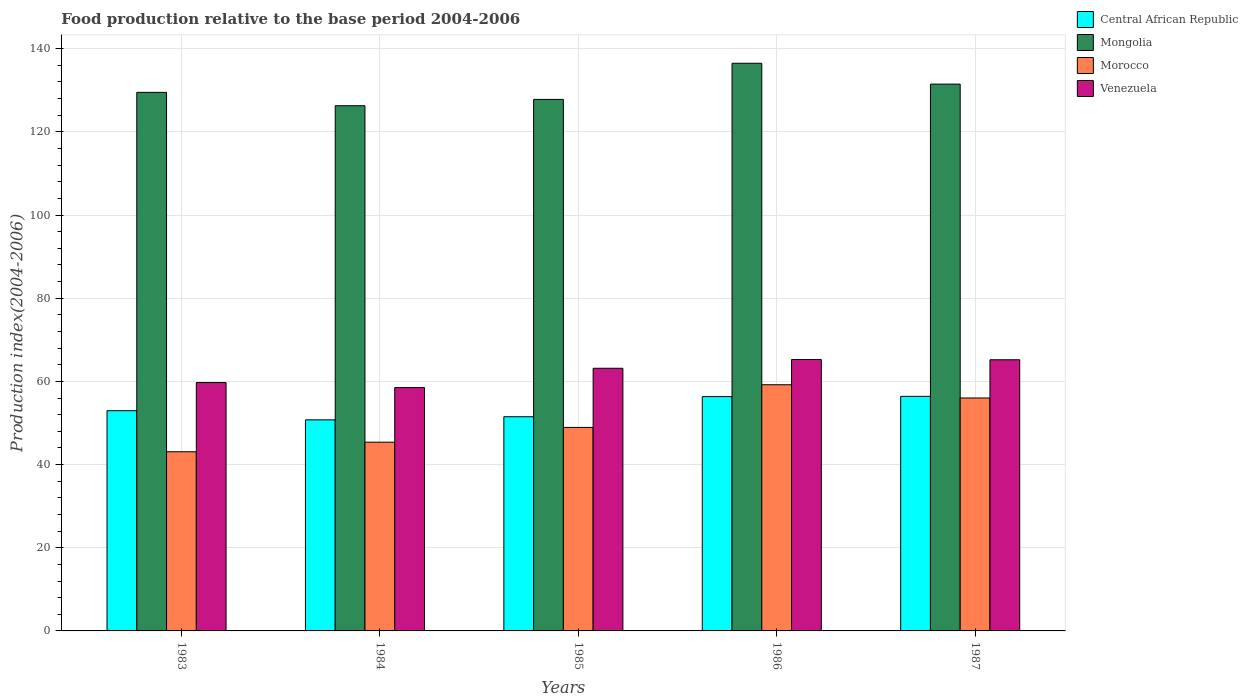How many different coloured bars are there?
Ensure brevity in your answer.  4. How many groups of bars are there?
Keep it short and to the point. 5. Are the number of bars per tick equal to the number of legend labels?
Give a very brief answer. Yes. How many bars are there on the 1st tick from the right?
Keep it short and to the point. 4. What is the label of the 5th group of bars from the left?
Provide a short and direct response. 1987. In how many cases, is the number of bars for a given year not equal to the number of legend labels?
Offer a terse response. 0. What is the food production index in Morocco in 1985?
Make the answer very short. 48.93. Across all years, what is the maximum food production index in Central African Republic?
Your answer should be very brief. 56.4. Across all years, what is the minimum food production index in Central African Republic?
Offer a very short reply. 50.75. In which year was the food production index in Venezuela maximum?
Provide a succinct answer. 1986. What is the total food production index in Venezuela in the graph?
Your response must be concise. 311.84. What is the difference between the food production index in Central African Republic in 1983 and that in 1986?
Ensure brevity in your answer.  -3.39. What is the difference between the food production index in Venezuela in 1987 and the food production index in Morocco in 1984?
Provide a short and direct response. 19.82. What is the average food production index in Central African Republic per year?
Provide a short and direct response. 53.59. In the year 1986, what is the difference between the food production index in Central African Republic and food production index in Morocco?
Ensure brevity in your answer.  -2.85. In how many years, is the food production index in Venezuela greater than 72?
Your response must be concise. 0. What is the ratio of the food production index in Venezuela in 1985 to that in 1987?
Your answer should be very brief. 0.97. What is the difference between the highest and the second highest food production index in Mongolia?
Ensure brevity in your answer.  5.01. What is the difference between the highest and the lowest food production index in Mongolia?
Your response must be concise. 10.21. Is it the case that in every year, the sum of the food production index in Venezuela and food production index in Morocco is greater than the sum of food production index in Mongolia and food production index in Central African Republic?
Provide a succinct answer. Yes. What does the 2nd bar from the left in 1987 represents?
Provide a short and direct response. Mongolia. What does the 2nd bar from the right in 1985 represents?
Ensure brevity in your answer.  Morocco. Is it the case that in every year, the sum of the food production index in Venezuela and food production index in Central African Republic is greater than the food production index in Morocco?
Provide a short and direct response. Yes. How many bars are there?
Make the answer very short. 20. How many years are there in the graph?
Provide a short and direct response. 5. What is the difference between two consecutive major ticks on the Y-axis?
Ensure brevity in your answer.  20. Does the graph contain any zero values?
Your answer should be compact. No. Does the graph contain grids?
Offer a terse response. Yes. How many legend labels are there?
Your answer should be very brief. 4. How are the legend labels stacked?
Offer a very short reply. Vertical. What is the title of the graph?
Your response must be concise. Food production relative to the base period 2004-2006. Does "Caribbean small states" appear as one of the legend labels in the graph?
Make the answer very short. No. What is the label or title of the X-axis?
Your response must be concise. Years. What is the label or title of the Y-axis?
Keep it short and to the point. Production index(2004-2006). What is the Production index(2004-2006) in Central African Republic in 1983?
Make the answer very short. 52.95. What is the Production index(2004-2006) in Mongolia in 1983?
Your answer should be compact. 129.49. What is the Production index(2004-2006) in Morocco in 1983?
Ensure brevity in your answer.  43.08. What is the Production index(2004-2006) in Venezuela in 1983?
Offer a terse response. 59.72. What is the Production index(2004-2006) of Central African Republic in 1984?
Provide a succinct answer. 50.75. What is the Production index(2004-2006) of Mongolia in 1984?
Offer a terse response. 126.28. What is the Production index(2004-2006) in Morocco in 1984?
Your answer should be very brief. 45.38. What is the Production index(2004-2006) of Venezuela in 1984?
Your response must be concise. 58.51. What is the Production index(2004-2006) of Central African Republic in 1985?
Ensure brevity in your answer.  51.5. What is the Production index(2004-2006) of Mongolia in 1985?
Offer a very short reply. 127.8. What is the Production index(2004-2006) in Morocco in 1985?
Provide a short and direct response. 48.93. What is the Production index(2004-2006) of Venezuela in 1985?
Your response must be concise. 63.15. What is the Production index(2004-2006) in Central African Republic in 1986?
Keep it short and to the point. 56.34. What is the Production index(2004-2006) of Mongolia in 1986?
Your answer should be very brief. 136.49. What is the Production index(2004-2006) in Morocco in 1986?
Give a very brief answer. 59.19. What is the Production index(2004-2006) of Venezuela in 1986?
Provide a short and direct response. 65.26. What is the Production index(2004-2006) of Central African Republic in 1987?
Offer a terse response. 56.4. What is the Production index(2004-2006) of Mongolia in 1987?
Offer a terse response. 131.48. What is the Production index(2004-2006) of Morocco in 1987?
Ensure brevity in your answer.  56.01. What is the Production index(2004-2006) of Venezuela in 1987?
Keep it short and to the point. 65.2. Across all years, what is the maximum Production index(2004-2006) in Central African Republic?
Your answer should be compact. 56.4. Across all years, what is the maximum Production index(2004-2006) in Mongolia?
Provide a short and direct response. 136.49. Across all years, what is the maximum Production index(2004-2006) in Morocco?
Your answer should be compact. 59.19. Across all years, what is the maximum Production index(2004-2006) of Venezuela?
Your answer should be compact. 65.26. Across all years, what is the minimum Production index(2004-2006) of Central African Republic?
Make the answer very short. 50.75. Across all years, what is the minimum Production index(2004-2006) in Mongolia?
Offer a terse response. 126.28. Across all years, what is the minimum Production index(2004-2006) of Morocco?
Your response must be concise. 43.08. Across all years, what is the minimum Production index(2004-2006) of Venezuela?
Offer a very short reply. 58.51. What is the total Production index(2004-2006) in Central African Republic in the graph?
Your answer should be very brief. 267.94. What is the total Production index(2004-2006) of Mongolia in the graph?
Your answer should be compact. 651.54. What is the total Production index(2004-2006) in Morocco in the graph?
Your answer should be compact. 252.59. What is the total Production index(2004-2006) of Venezuela in the graph?
Keep it short and to the point. 311.84. What is the difference between the Production index(2004-2006) of Mongolia in 1983 and that in 1984?
Offer a very short reply. 3.21. What is the difference between the Production index(2004-2006) in Venezuela in 1983 and that in 1984?
Your response must be concise. 1.21. What is the difference between the Production index(2004-2006) of Central African Republic in 1983 and that in 1985?
Give a very brief answer. 1.45. What is the difference between the Production index(2004-2006) in Mongolia in 1983 and that in 1985?
Keep it short and to the point. 1.69. What is the difference between the Production index(2004-2006) of Morocco in 1983 and that in 1985?
Your answer should be very brief. -5.85. What is the difference between the Production index(2004-2006) of Venezuela in 1983 and that in 1985?
Offer a very short reply. -3.43. What is the difference between the Production index(2004-2006) of Central African Republic in 1983 and that in 1986?
Provide a short and direct response. -3.39. What is the difference between the Production index(2004-2006) in Morocco in 1983 and that in 1986?
Ensure brevity in your answer.  -16.11. What is the difference between the Production index(2004-2006) of Venezuela in 1983 and that in 1986?
Your response must be concise. -5.54. What is the difference between the Production index(2004-2006) of Central African Republic in 1983 and that in 1987?
Your answer should be compact. -3.45. What is the difference between the Production index(2004-2006) of Mongolia in 1983 and that in 1987?
Make the answer very short. -1.99. What is the difference between the Production index(2004-2006) of Morocco in 1983 and that in 1987?
Keep it short and to the point. -12.93. What is the difference between the Production index(2004-2006) of Venezuela in 1983 and that in 1987?
Your answer should be very brief. -5.48. What is the difference between the Production index(2004-2006) in Central African Republic in 1984 and that in 1985?
Offer a very short reply. -0.75. What is the difference between the Production index(2004-2006) of Mongolia in 1984 and that in 1985?
Keep it short and to the point. -1.52. What is the difference between the Production index(2004-2006) of Morocco in 1984 and that in 1985?
Provide a short and direct response. -3.55. What is the difference between the Production index(2004-2006) in Venezuela in 1984 and that in 1985?
Offer a terse response. -4.64. What is the difference between the Production index(2004-2006) of Central African Republic in 1984 and that in 1986?
Keep it short and to the point. -5.59. What is the difference between the Production index(2004-2006) of Mongolia in 1984 and that in 1986?
Give a very brief answer. -10.21. What is the difference between the Production index(2004-2006) of Morocco in 1984 and that in 1986?
Ensure brevity in your answer.  -13.81. What is the difference between the Production index(2004-2006) in Venezuela in 1984 and that in 1986?
Your answer should be very brief. -6.75. What is the difference between the Production index(2004-2006) of Central African Republic in 1984 and that in 1987?
Your response must be concise. -5.65. What is the difference between the Production index(2004-2006) of Mongolia in 1984 and that in 1987?
Your answer should be very brief. -5.2. What is the difference between the Production index(2004-2006) of Morocco in 1984 and that in 1987?
Your answer should be compact. -10.63. What is the difference between the Production index(2004-2006) in Venezuela in 1984 and that in 1987?
Ensure brevity in your answer.  -6.69. What is the difference between the Production index(2004-2006) of Central African Republic in 1985 and that in 1986?
Give a very brief answer. -4.84. What is the difference between the Production index(2004-2006) in Mongolia in 1985 and that in 1986?
Offer a very short reply. -8.69. What is the difference between the Production index(2004-2006) of Morocco in 1985 and that in 1986?
Provide a succinct answer. -10.26. What is the difference between the Production index(2004-2006) in Venezuela in 1985 and that in 1986?
Your response must be concise. -2.11. What is the difference between the Production index(2004-2006) of Central African Republic in 1985 and that in 1987?
Offer a terse response. -4.9. What is the difference between the Production index(2004-2006) of Mongolia in 1985 and that in 1987?
Offer a terse response. -3.68. What is the difference between the Production index(2004-2006) of Morocco in 1985 and that in 1987?
Keep it short and to the point. -7.08. What is the difference between the Production index(2004-2006) in Venezuela in 1985 and that in 1987?
Give a very brief answer. -2.05. What is the difference between the Production index(2004-2006) in Central African Republic in 1986 and that in 1987?
Your answer should be very brief. -0.06. What is the difference between the Production index(2004-2006) of Mongolia in 1986 and that in 1987?
Keep it short and to the point. 5.01. What is the difference between the Production index(2004-2006) in Morocco in 1986 and that in 1987?
Give a very brief answer. 3.18. What is the difference between the Production index(2004-2006) of Central African Republic in 1983 and the Production index(2004-2006) of Mongolia in 1984?
Keep it short and to the point. -73.33. What is the difference between the Production index(2004-2006) in Central African Republic in 1983 and the Production index(2004-2006) in Morocco in 1984?
Your response must be concise. 7.57. What is the difference between the Production index(2004-2006) of Central African Republic in 1983 and the Production index(2004-2006) of Venezuela in 1984?
Make the answer very short. -5.56. What is the difference between the Production index(2004-2006) of Mongolia in 1983 and the Production index(2004-2006) of Morocco in 1984?
Provide a succinct answer. 84.11. What is the difference between the Production index(2004-2006) in Mongolia in 1983 and the Production index(2004-2006) in Venezuela in 1984?
Your response must be concise. 70.98. What is the difference between the Production index(2004-2006) in Morocco in 1983 and the Production index(2004-2006) in Venezuela in 1984?
Your answer should be compact. -15.43. What is the difference between the Production index(2004-2006) in Central African Republic in 1983 and the Production index(2004-2006) in Mongolia in 1985?
Provide a short and direct response. -74.85. What is the difference between the Production index(2004-2006) of Central African Republic in 1983 and the Production index(2004-2006) of Morocco in 1985?
Ensure brevity in your answer.  4.02. What is the difference between the Production index(2004-2006) in Mongolia in 1983 and the Production index(2004-2006) in Morocco in 1985?
Your answer should be very brief. 80.56. What is the difference between the Production index(2004-2006) of Mongolia in 1983 and the Production index(2004-2006) of Venezuela in 1985?
Provide a short and direct response. 66.34. What is the difference between the Production index(2004-2006) in Morocco in 1983 and the Production index(2004-2006) in Venezuela in 1985?
Offer a terse response. -20.07. What is the difference between the Production index(2004-2006) in Central African Republic in 1983 and the Production index(2004-2006) in Mongolia in 1986?
Your response must be concise. -83.54. What is the difference between the Production index(2004-2006) in Central African Republic in 1983 and the Production index(2004-2006) in Morocco in 1986?
Ensure brevity in your answer.  -6.24. What is the difference between the Production index(2004-2006) of Central African Republic in 1983 and the Production index(2004-2006) of Venezuela in 1986?
Give a very brief answer. -12.31. What is the difference between the Production index(2004-2006) of Mongolia in 1983 and the Production index(2004-2006) of Morocco in 1986?
Your answer should be very brief. 70.3. What is the difference between the Production index(2004-2006) in Mongolia in 1983 and the Production index(2004-2006) in Venezuela in 1986?
Offer a very short reply. 64.23. What is the difference between the Production index(2004-2006) of Morocco in 1983 and the Production index(2004-2006) of Venezuela in 1986?
Give a very brief answer. -22.18. What is the difference between the Production index(2004-2006) of Central African Republic in 1983 and the Production index(2004-2006) of Mongolia in 1987?
Your answer should be very brief. -78.53. What is the difference between the Production index(2004-2006) of Central African Republic in 1983 and the Production index(2004-2006) of Morocco in 1987?
Keep it short and to the point. -3.06. What is the difference between the Production index(2004-2006) in Central African Republic in 1983 and the Production index(2004-2006) in Venezuela in 1987?
Your answer should be very brief. -12.25. What is the difference between the Production index(2004-2006) of Mongolia in 1983 and the Production index(2004-2006) of Morocco in 1987?
Keep it short and to the point. 73.48. What is the difference between the Production index(2004-2006) in Mongolia in 1983 and the Production index(2004-2006) in Venezuela in 1987?
Your answer should be very brief. 64.29. What is the difference between the Production index(2004-2006) in Morocco in 1983 and the Production index(2004-2006) in Venezuela in 1987?
Provide a short and direct response. -22.12. What is the difference between the Production index(2004-2006) of Central African Republic in 1984 and the Production index(2004-2006) of Mongolia in 1985?
Offer a very short reply. -77.05. What is the difference between the Production index(2004-2006) of Central African Republic in 1984 and the Production index(2004-2006) of Morocco in 1985?
Provide a succinct answer. 1.82. What is the difference between the Production index(2004-2006) of Mongolia in 1984 and the Production index(2004-2006) of Morocco in 1985?
Your answer should be compact. 77.35. What is the difference between the Production index(2004-2006) in Mongolia in 1984 and the Production index(2004-2006) in Venezuela in 1985?
Offer a terse response. 63.13. What is the difference between the Production index(2004-2006) of Morocco in 1984 and the Production index(2004-2006) of Venezuela in 1985?
Keep it short and to the point. -17.77. What is the difference between the Production index(2004-2006) in Central African Republic in 1984 and the Production index(2004-2006) in Mongolia in 1986?
Ensure brevity in your answer.  -85.74. What is the difference between the Production index(2004-2006) in Central African Republic in 1984 and the Production index(2004-2006) in Morocco in 1986?
Provide a short and direct response. -8.44. What is the difference between the Production index(2004-2006) of Central African Republic in 1984 and the Production index(2004-2006) of Venezuela in 1986?
Make the answer very short. -14.51. What is the difference between the Production index(2004-2006) of Mongolia in 1984 and the Production index(2004-2006) of Morocco in 1986?
Your answer should be very brief. 67.09. What is the difference between the Production index(2004-2006) of Mongolia in 1984 and the Production index(2004-2006) of Venezuela in 1986?
Keep it short and to the point. 61.02. What is the difference between the Production index(2004-2006) in Morocco in 1984 and the Production index(2004-2006) in Venezuela in 1986?
Give a very brief answer. -19.88. What is the difference between the Production index(2004-2006) in Central African Republic in 1984 and the Production index(2004-2006) in Mongolia in 1987?
Keep it short and to the point. -80.73. What is the difference between the Production index(2004-2006) of Central African Republic in 1984 and the Production index(2004-2006) of Morocco in 1987?
Ensure brevity in your answer.  -5.26. What is the difference between the Production index(2004-2006) of Central African Republic in 1984 and the Production index(2004-2006) of Venezuela in 1987?
Keep it short and to the point. -14.45. What is the difference between the Production index(2004-2006) in Mongolia in 1984 and the Production index(2004-2006) in Morocco in 1987?
Offer a terse response. 70.27. What is the difference between the Production index(2004-2006) of Mongolia in 1984 and the Production index(2004-2006) of Venezuela in 1987?
Ensure brevity in your answer.  61.08. What is the difference between the Production index(2004-2006) of Morocco in 1984 and the Production index(2004-2006) of Venezuela in 1987?
Ensure brevity in your answer.  -19.82. What is the difference between the Production index(2004-2006) of Central African Republic in 1985 and the Production index(2004-2006) of Mongolia in 1986?
Ensure brevity in your answer.  -84.99. What is the difference between the Production index(2004-2006) of Central African Republic in 1985 and the Production index(2004-2006) of Morocco in 1986?
Ensure brevity in your answer.  -7.69. What is the difference between the Production index(2004-2006) of Central African Republic in 1985 and the Production index(2004-2006) of Venezuela in 1986?
Offer a very short reply. -13.76. What is the difference between the Production index(2004-2006) of Mongolia in 1985 and the Production index(2004-2006) of Morocco in 1986?
Give a very brief answer. 68.61. What is the difference between the Production index(2004-2006) of Mongolia in 1985 and the Production index(2004-2006) of Venezuela in 1986?
Your response must be concise. 62.54. What is the difference between the Production index(2004-2006) in Morocco in 1985 and the Production index(2004-2006) in Venezuela in 1986?
Your answer should be very brief. -16.33. What is the difference between the Production index(2004-2006) in Central African Republic in 1985 and the Production index(2004-2006) in Mongolia in 1987?
Your response must be concise. -79.98. What is the difference between the Production index(2004-2006) of Central African Republic in 1985 and the Production index(2004-2006) of Morocco in 1987?
Offer a very short reply. -4.51. What is the difference between the Production index(2004-2006) in Central African Republic in 1985 and the Production index(2004-2006) in Venezuela in 1987?
Give a very brief answer. -13.7. What is the difference between the Production index(2004-2006) in Mongolia in 1985 and the Production index(2004-2006) in Morocco in 1987?
Make the answer very short. 71.79. What is the difference between the Production index(2004-2006) of Mongolia in 1985 and the Production index(2004-2006) of Venezuela in 1987?
Your response must be concise. 62.6. What is the difference between the Production index(2004-2006) of Morocco in 1985 and the Production index(2004-2006) of Venezuela in 1987?
Provide a short and direct response. -16.27. What is the difference between the Production index(2004-2006) in Central African Republic in 1986 and the Production index(2004-2006) in Mongolia in 1987?
Your answer should be very brief. -75.14. What is the difference between the Production index(2004-2006) in Central African Republic in 1986 and the Production index(2004-2006) in Morocco in 1987?
Your response must be concise. 0.33. What is the difference between the Production index(2004-2006) of Central African Republic in 1986 and the Production index(2004-2006) of Venezuela in 1987?
Your answer should be very brief. -8.86. What is the difference between the Production index(2004-2006) in Mongolia in 1986 and the Production index(2004-2006) in Morocco in 1987?
Your answer should be very brief. 80.48. What is the difference between the Production index(2004-2006) in Mongolia in 1986 and the Production index(2004-2006) in Venezuela in 1987?
Keep it short and to the point. 71.29. What is the difference between the Production index(2004-2006) of Morocco in 1986 and the Production index(2004-2006) of Venezuela in 1987?
Keep it short and to the point. -6.01. What is the average Production index(2004-2006) in Central African Republic per year?
Your answer should be compact. 53.59. What is the average Production index(2004-2006) of Mongolia per year?
Ensure brevity in your answer.  130.31. What is the average Production index(2004-2006) in Morocco per year?
Provide a succinct answer. 50.52. What is the average Production index(2004-2006) of Venezuela per year?
Your answer should be compact. 62.37. In the year 1983, what is the difference between the Production index(2004-2006) of Central African Republic and Production index(2004-2006) of Mongolia?
Provide a succinct answer. -76.54. In the year 1983, what is the difference between the Production index(2004-2006) in Central African Republic and Production index(2004-2006) in Morocco?
Keep it short and to the point. 9.87. In the year 1983, what is the difference between the Production index(2004-2006) in Central African Republic and Production index(2004-2006) in Venezuela?
Your response must be concise. -6.77. In the year 1983, what is the difference between the Production index(2004-2006) of Mongolia and Production index(2004-2006) of Morocco?
Give a very brief answer. 86.41. In the year 1983, what is the difference between the Production index(2004-2006) in Mongolia and Production index(2004-2006) in Venezuela?
Keep it short and to the point. 69.77. In the year 1983, what is the difference between the Production index(2004-2006) of Morocco and Production index(2004-2006) of Venezuela?
Your answer should be compact. -16.64. In the year 1984, what is the difference between the Production index(2004-2006) of Central African Republic and Production index(2004-2006) of Mongolia?
Give a very brief answer. -75.53. In the year 1984, what is the difference between the Production index(2004-2006) in Central African Republic and Production index(2004-2006) in Morocco?
Provide a short and direct response. 5.37. In the year 1984, what is the difference between the Production index(2004-2006) in Central African Republic and Production index(2004-2006) in Venezuela?
Your answer should be compact. -7.76. In the year 1984, what is the difference between the Production index(2004-2006) in Mongolia and Production index(2004-2006) in Morocco?
Your answer should be very brief. 80.9. In the year 1984, what is the difference between the Production index(2004-2006) of Mongolia and Production index(2004-2006) of Venezuela?
Provide a succinct answer. 67.77. In the year 1984, what is the difference between the Production index(2004-2006) in Morocco and Production index(2004-2006) in Venezuela?
Your response must be concise. -13.13. In the year 1985, what is the difference between the Production index(2004-2006) in Central African Republic and Production index(2004-2006) in Mongolia?
Ensure brevity in your answer.  -76.3. In the year 1985, what is the difference between the Production index(2004-2006) of Central African Republic and Production index(2004-2006) of Morocco?
Provide a succinct answer. 2.57. In the year 1985, what is the difference between the Production index(2004-2006) of Central African Republic and Production index(2004-2006) of Venezuela?
Your response must be concise. -11.65. In the year 1985, what is the difference between the Production index(2004-2006) of Mongolia and Production index(2004-2006) of Morocco?
Offer a very short reply. 78.87. In the year 1985, what is the difference between the Production index(2004-2006) of Mongolia and Production index(2004-2006) of Venezuela?
Offer a terse response. 64.65. In the year 1985, what is the difference between the Production index(2004-2006) in Morocco and Production index(2004-2006) in Venezuela?
Make the answer very short. -14.22. In the year 1986, what is the difference between the Production index(2004-2006) of Central African Republic and Production index(2004-2006) of Mongolia?
Offer a very short reply. -80.15. In the year 1986, what is the difference between the Production index(2004-2006) of Central African Republic and Production index(2004-2006) of Morocco?
Keep it short and to the point. -2.85. In the year 1986, what is the difference between the Production index(2004-2006) of Central African Republic and Production index(2004-2006) of Venezuela?
Provide a succinct answer. -8.92. In the year 1986, what is the difference between the Production index(2004-2006) of Mongolia and Production index(2004-2006) of Morocco?
Offer a terse response. 77.3. In the year 1986, what is the difference between the Production index(2004-2006) in Mongolia and Production index(2004-2006) in Venezuela?
Offer a very short reply. 71.23. In the year 1986, what is the difference between the Production index(2004-2006) in Morocco and Production index(2004-2006) in Venezuela?
Make the answer very short. -6.07. In the year 1987, what is the difference between the Production index(2004-2006) of Central African Republic and Production index(2004-2006) of Mongolia?
Your response must be concise. -75.08. In the year 1987, what is the difference between the Production index(2004-2006) in Central African Republic and Production index(2004-2006) in Morocco?
Your answer should be compact. 0.39. In the year 1987, what is the difference between the Production index(2004-2006) of Mongolia and Production index(2004-2006) of Morocco?
Provide a succinct answer. 75.47. In the year 1987, what is the difference between the Production index(2004-2006) of Mongolia and Production index(2004-2006) of Venezuela?
Your answer should be very brief. 66.28. In the year 1987, what is the difference between the Production index(2004-2006) of Morocco and Production index(2004-2006) of Venezuela?
Offer a terse response. -9.19. What is the ratio of the Production index(2004-2006) in Central African Republic in 1983 to that in 1984?
Ensure brevity in your answer.  1.04. What is the ratio of the Production index(2004-2006) of Mongolia in 1983 to that in 1984?
Make the answer very short. 1.03. What is the ratio of the Production index(2004-2006) in Morocco in 1983 to that in 1984?
Your answer should be very brief. 0.95. What is the ratio of the Production index(2004-2006) in Venezuela in 1983 to that in 1984?
Give a very brief answer. 1.02. What is the ratio of the Production index(2004-2006) of Central African Republic in 1983 to that in 1985?
Offer a very short reply. 1.03. What is the ratio of the Production index(2004-2006) in Mongolia in 1983 to that in 1985?
Offer a very short reply. 1.01. What is the ratio of the Production index(2004-2006) in Morocco in 1983 to that in 1985?
Give a very brief answer. 0.88. What is the ratio of the Production index(2004-2006) in Venezuela in 1983 to that in 1985?
Keep it short and to the point. 0.95. What is the ratio of the Production index(2004-2006) of Central African Republic in 1983 to that in 1986?
Ensure brevity in your answer.  0.94. What is the ratio of the Production index(2004-2006) in Mongolia in 1983 to that in 1986?
Ensure brevity in your answer.  0.95. What is the ratio of the Production index(2004-2006) in Morocco in 1983 to that in 1986?
Ensure brevity in your answer.  0.73. What is the ratio of the Production index(2004-2006) in Venezuela in 1983 to that in 1986?
Your answer should be compact. 0.92. What is the ratio of the Production index(2004-2006) of Central African Republic in 1983 to that in 1987?
Make the answer very short. 0.94. What is the ratio of the Production index(2004-2006) of Mongolia in 1983 to that in 1987?
Your answer should be compact. 0.98. What is the ratio of the Production index(2004-2006) of Morocco in 1983 to that in 1987?
Your answer should be compact. 0.77. What is the ratio of the Production index(2004-2006) of Venezuela in 1983 to that in 1987?
Ensure brevity in your answer.  0.92. What is the ratio of the Production index(2004-2006) in Central African Republic in 1984 to that in 1985?
Make the answer very short. 0.99. What is the ratio of the Production index(2004-2006) in Mongolia in 1984 to that in 1985?
Keep it short and to the point. 0.99. What is the ratio of the Production index(2004-2006) of Morocco in 1984 to that in 1985?
Make the answer very short. 0.93. What is the ratio of the Production index(2004-2006) in Venezuela in 1984 to that in 1985?
Make the answer very short. 0.93. What is the ratio of the Production index(2004-2006) in Central African Republic in 1984 to that in 1986?
Give a very brief answer. 0.9. What is the ratio of the Production index(2004-2006) of Mongolia in 1984 to that in 1986?
Make the answer very short. 0.93. What is the ratio of the Production index(2004-2006) in Morocco in 1984 to that in 1986?
Make the answer very short. 0.77. What is the ratio of the Production index(2004-2006) of Venezuela in 1984 to that in 1986?
Keep it short and to the point. 0.9. What is the ratio of the Production index(2004-2006) of Central African Republic in 1984 to that in 1987?
Ensure brevity in your answer.  0.9. What is the ratio of the Production index(2004-2006) of Mongolia in 1984 to that in 1987?
Make the answer very short. 0.96. What is the ratio of the Production index(2004-2006) of Morocco in 1984 to that in 1987?
Your answer should be very brief. 0.81. What is the ratio of the Production index(2004-2006) in Venezuela in 1984 to that in 1987?
Offer a very short reply. 0.9. What is the ratio of the Production index(2004-2006) in Central African Republic in 1985 to that in 1986?
Your answer should be very brief. 0.91. What is the ratio of the Production index(2004-2006) in Mongolia in 1985 to that in 1986?
Provide a short and direct response. 0.94. What is the ratio of the Production index(2004-2006) of Morocco in 1985 to that in 1986?
Your answer should be very brief. 0.83. What is the ratio of the Production index(2004-2006) in Central African Republic in 1985 to that in 1987?
Your answer should be very brief. 0.91. What is the ratio of the Production index(2004-2006) of Morocco in 1985 to that in 1987?
Make the answer very short. 0.87. What is the ratio of the Production index(2004-2006) in Venezuela in 1985 to that in 1987?
Your response must be concise. 0.97. What is the ratio of the Production index(2004-2006) in Central African Republic in 1986 to that in 1987?
Offer a very short reply. 1. What is the ratio of the Production index(2004-2006) in Mongolia in 1986 to that in 1987?
Give a very brief answer. 1.04. What is the ratio of the Production index(2004-2006) in Morocco in 1986 to that in 1987?
Give a very brief answer. 1.06. What is the difference between the highest and the second highest Production index(2004-2006) in Mongolia?
Offer a terse response. 5.01. What is the difference between the highest and the second highest Production index(2004-2006) of Morocco?
Provide a short and direct response. 3.18. What is the difference between the highest and the second highest Production index(2004-2006) of Venezuela?
Give a very brief answer. 0.06. What is the difference between the highest and the lowest Production index(2004-2006) in Central African Republic?
Provide a short and direct response. 5.65. What is the difference between the highest and the lowest Production index(2004-2006) in Mongolia?
Your answer should be compact. 10.21. What is the difference between the highest and the lowest Production index(2004-2006) in Morocco?
Give a very brief answer. 16.11. What is the difference between the highest and the lowest Production index(2004-2006) in Venezuela?
Offer a very short reply. 6.75. 